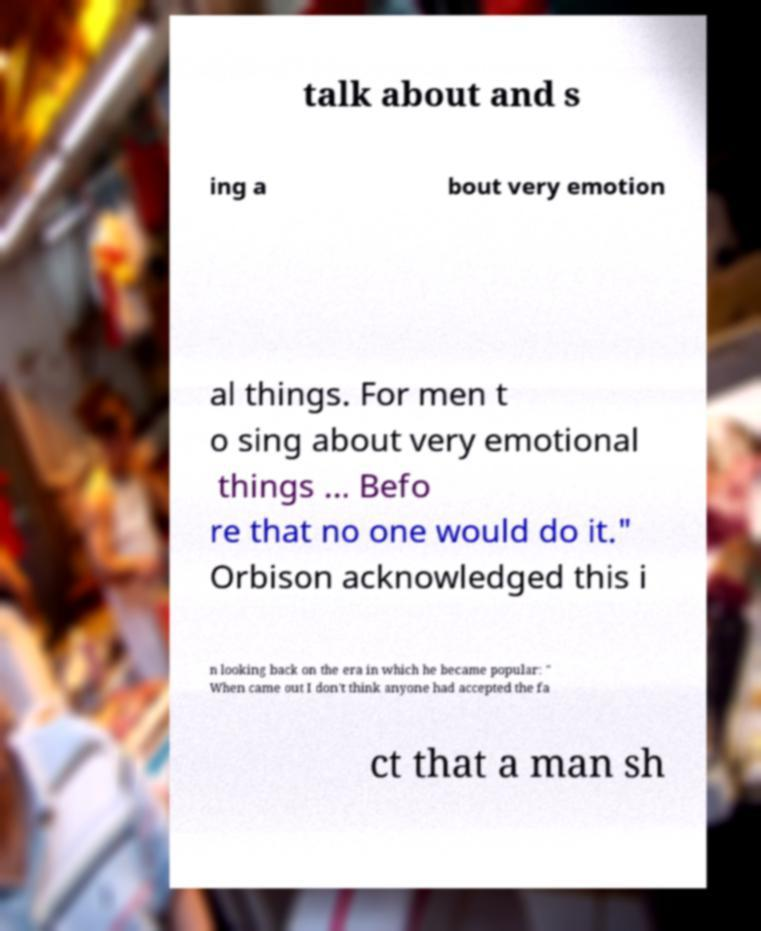Could you assist in decoding the text presented in this image and type it out clearly? talk about and s ing a bout very emotion al things. For men t o sing about very emotional things ... Befo re that no one would do it." Orbison acknowledged this i n looking back on the era in which he became popular: " When came out I don't think anyone had accepted the fa ct that a man sh 